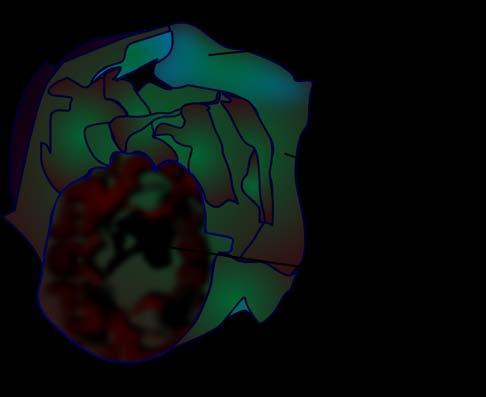what does the cyst wall show?
Answer the question using a single word or phrase. Presence of loculi containing gelatinous mucoid material 